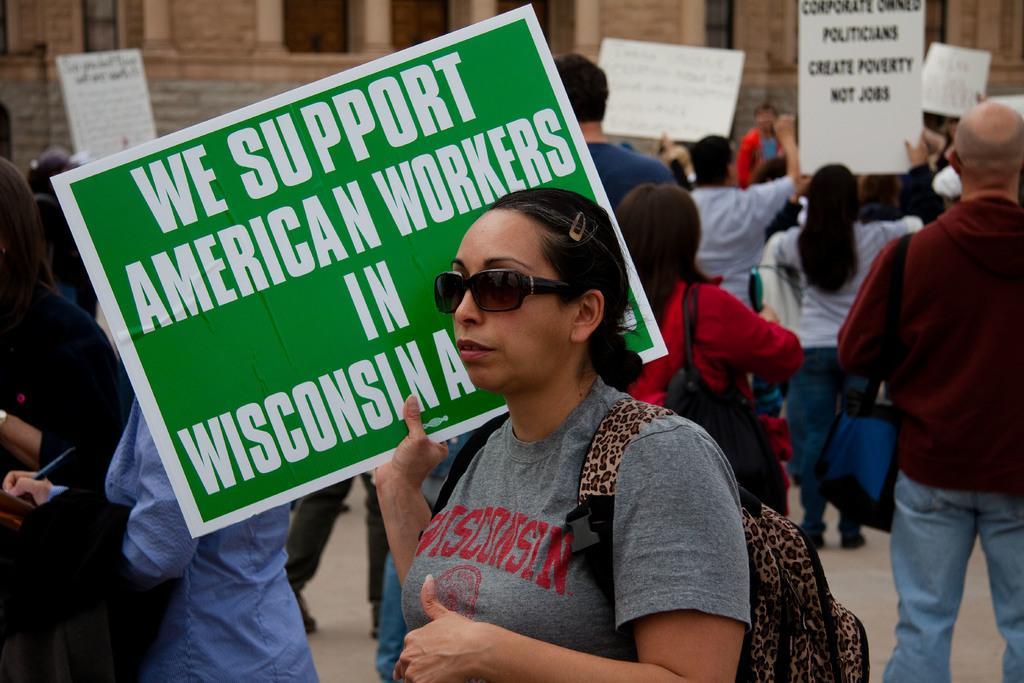Please provide a concise description of this image. In this picture I can see few people are standing and few are holding placards with some text and I can see couple for women wearing bags and I can see a human writing with the help of a pen and I can see building in the back. 